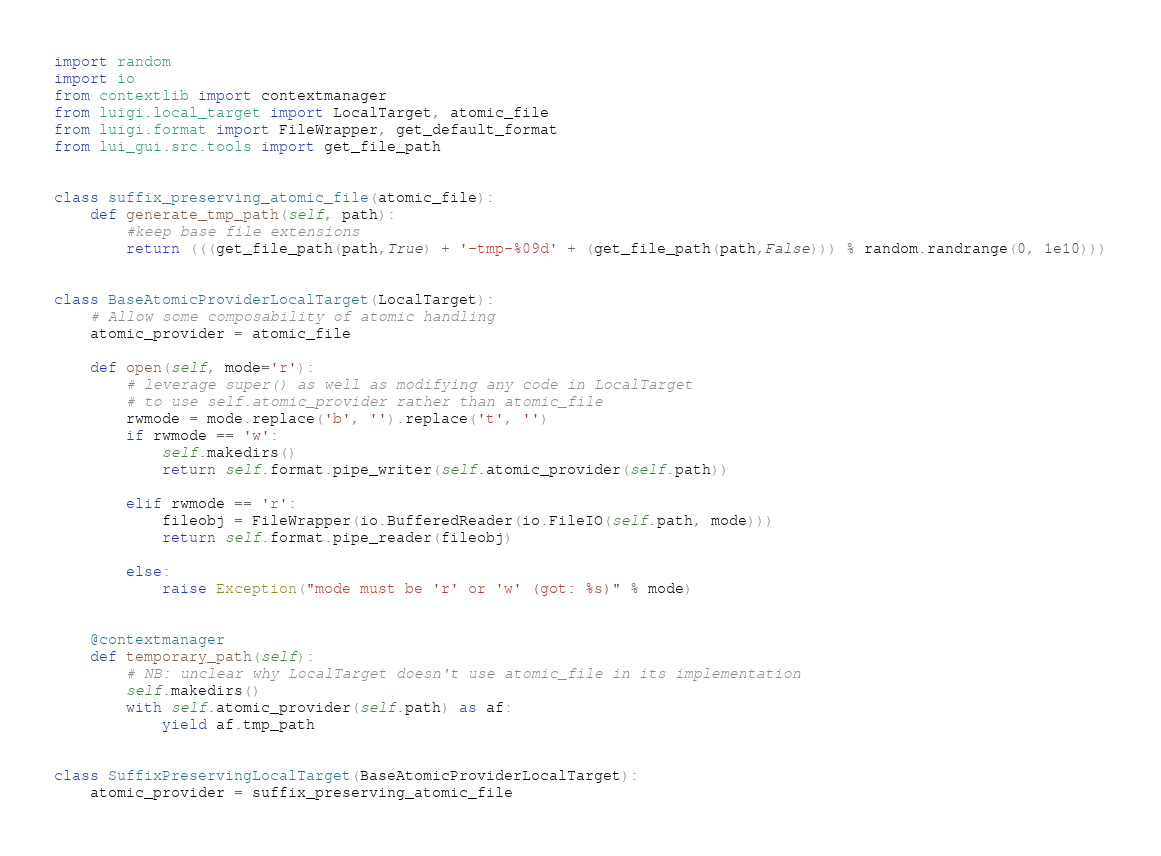<code> <loc_0><loc_0><loc_500><loc_500><_Python_>import random
import io
from contextlib import contextmanager
from luigi.local_target import LocalTarget, atomic_file
from luigi.format import FileWrapper, get_default_format
from lui_gui.src.tools import get_file_path


class suffix_preserving_atomic_file(atomic_file):
    def generate_tmp_path(self, path):
        #keep base file extensions
        return (((get_file_path(path,True) + '-tmp-%09d' + (get_file_path(path,False))) % random.randrange(0, 1e10)))


class BaseAtomicProviderLocalTarget(LocalTarget):
    # Allow some composability of atomic handling
    atomic_provider = atomic_file

    def open(self, mode='r'):
        # leverage super() as well as modifying any code in LocalTarget
        # to use self.atomic_provider rather than atomic_file
        rwmode = mode.replace('b', '').replace('t', '')
        if rwmode == 'w':
            self.makedirs()
            return self.format.pipe_writer(self.atomic_provider(self.path))

        elif rwmode == 'r':
            fileobj = FileWrapper(io.BufferedReader(io.FileIO(self.path, mode)))
            return self.format.pipe_reader(fileobj)

        else:
            raise Exception("mode must be 'r' or 'w' (got: %s)" % mode)


    @contextmanager
    def temporary_path(self):
        # NB: unclear why LocalTarget doesn't use atomic_file in its implementation
        self.makedirs()
        with self.atomic_provider(self.path) as af:
            yield af.tmp_path


class SuffixPreservingLocalTarget(BaseAtomicProviderLocalTarget):
    atomic_provider = suffix_preserving_atomic_file</code> 